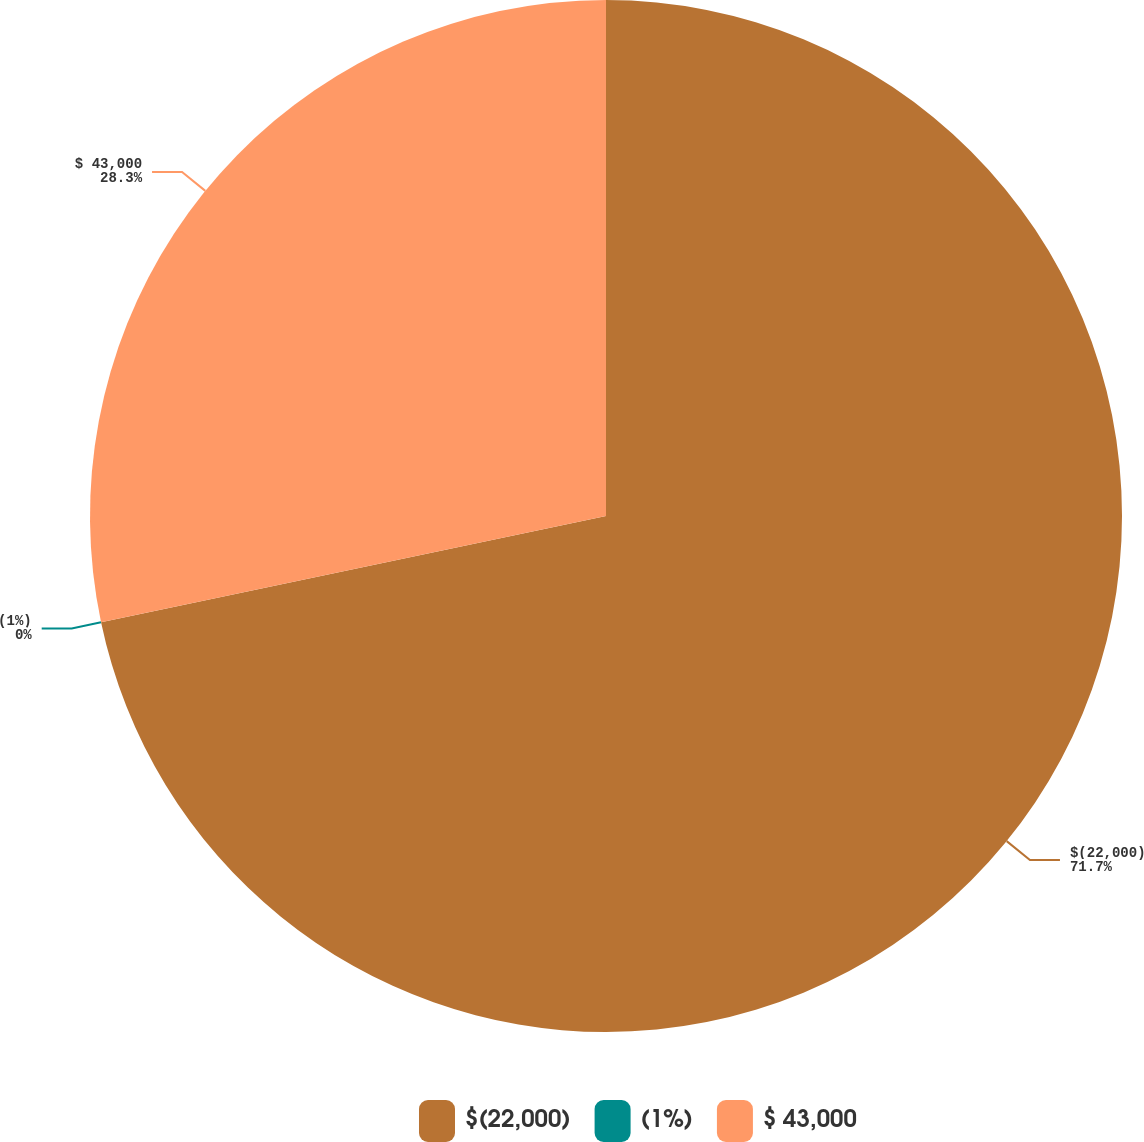Convert chart. <chart><loc_0><loc_0><loc_500><loc_500><pie_chart><fcel>$(22,000)<fcel>(1%)<fcel>$ 43,000<nl><fcel>71.7%<fcel>0.0%<fcel>28.3%<nl></chart> 